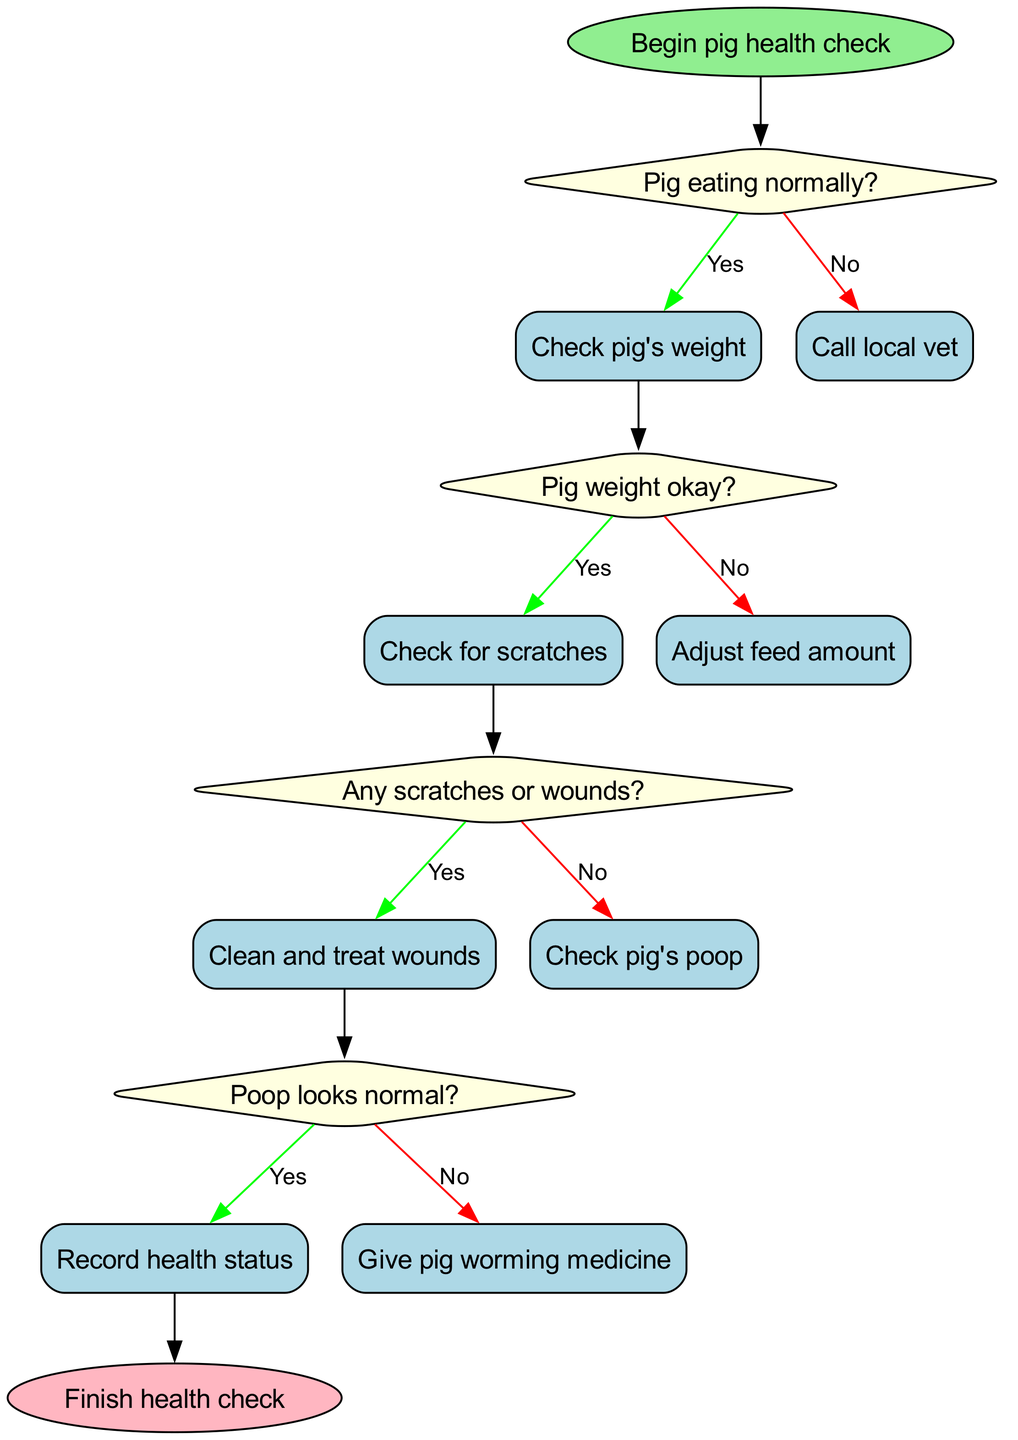What is the first action in the health check process? The first action in the health check process is the "Begin pig health check" step, which starts the flow of actions and decisions.
Answer: Begin pig health check How many decision nodes are there? There are four decision nodes present in the diagram, each asking a specific question regarding the pig's health.
Answer: 4 What action follows if the pig is not eating normally? If the pig is not eating normally, the next action is to "Call local vet" for further assistance regarding the health of the pig.
Answer: Call local vet What happens if the pig's weight is not okay? If the pig's weight is not okay, the next step is to "Adjust feed amount" to resolve the weight issue.
Answer: Adjust feed amount What do you check if the pig's poop looks abnormal? If the pig's poop looks abnormal, the action is to "Give pig worming medicine" to address any possible health issues.
Answer: Give pig worming medicine What is the final step of the health check process? The final step in the health check process is to "Finish health check," which indicates that all necessary actions and reviews have been completed.
Answer: Finish health check If the pig has scratches, what is the next action? If the pig has scratches or wounds, the action that follows is to "Clean and treat wounds" to ensure the pig's health and hygiene.
Answer: Clean and treat wounds What is the relationship between checking weight and checking for scratches? The relationship is that checking weight is an action that comes after confirming the pig is eating normally and is followed by checking for scratches if the weight is okay.
Answer: Action sequence 